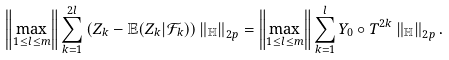Convert formula to latex. <formula><loc_0><loc_0><loc_500><loc_500>\left \| \underset { 1 \leq l \leq m } { \max } \right \| \sum _ { k = 1 } ^ { 2 l } \left ( Z _ { k } - \mathbb { E } ( Z _ { k } | \mathcal { F } _ { k } ) \right ) \left \| _ { \mathbb { H } } \right \| _ { 2 p } = \left \| \underset { 1 \leq l \leq m } { \max } \right \| \sum _ { k = 1 } ^ { l } Y _ { 0 } \circ T ^ { 2 k } \left \| _ { \mathbb { H } } \right \| _ { 2 p } .</formula> 